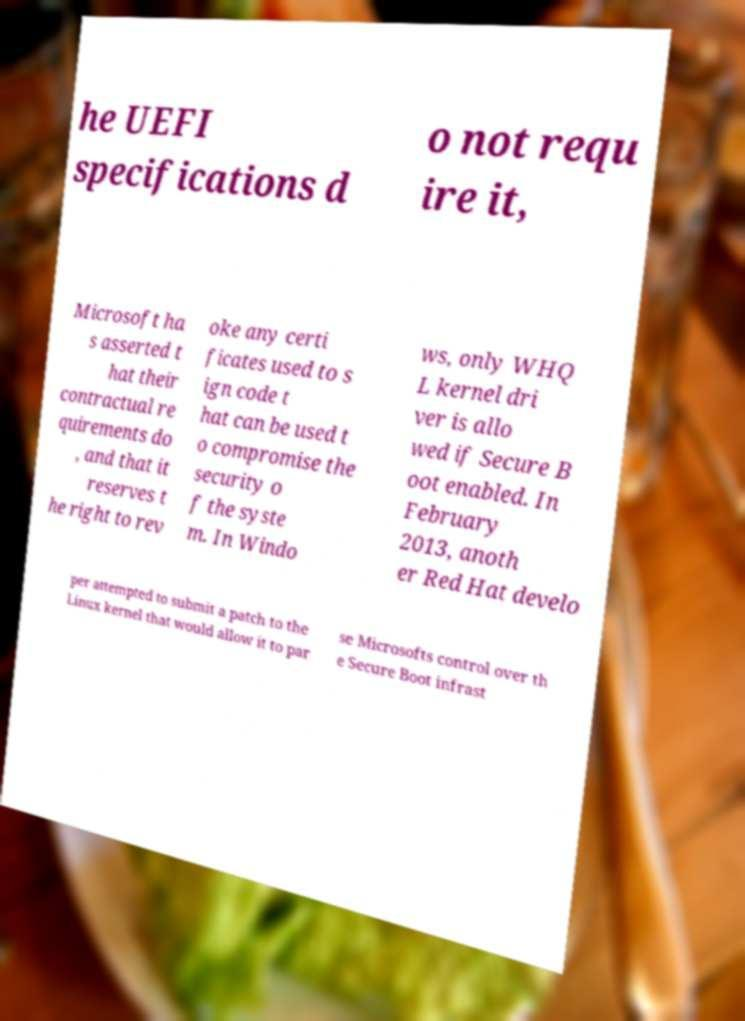Please identify and transcribe the text found in this image. he UEFI specifications d o not requ ire it, Microsoft ha s asserted t hat their contractual re quirements do , and that it reserves t he right to rev oke any certi ficates used to s ign code t hat can be used t o compromise the security o f the syste m. In Windo ws, only WHQ L kernel dri ver is allo wed if Secure B oot enabled. In February 2013, anoth er Red Hat develo per attempted to submit a patch to the Linux kernel that would allow it to par se Microsofts control over th e Secure Boot infrast 